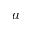Convert formula to latex. <formula><loc_0><loc_0><loc_500><loc_500>a</formula> 